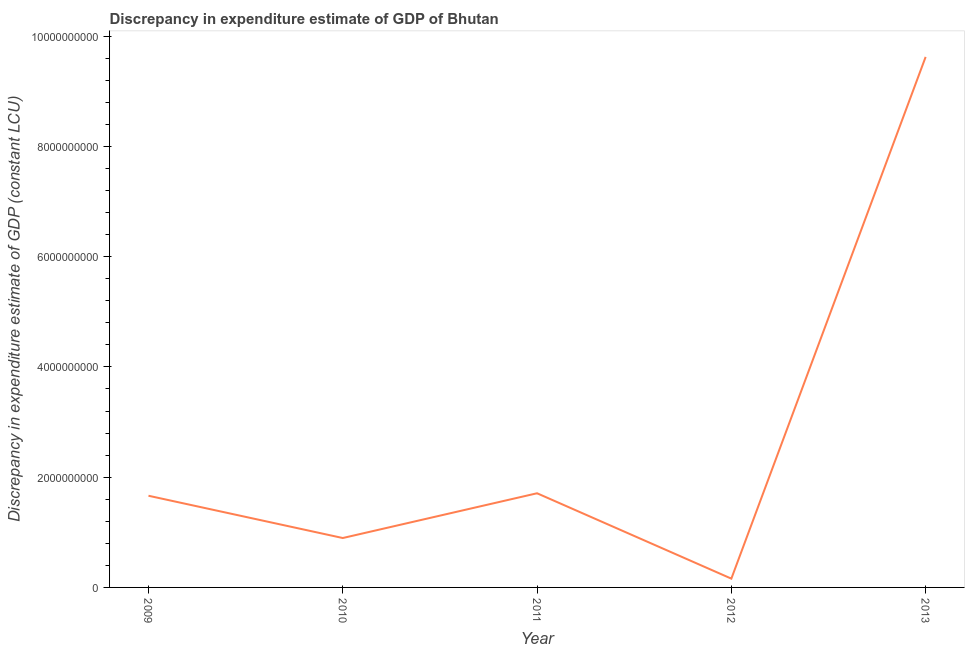What is the discrepancy in expenditure estimate of gdp in 2012?
Your answer should be compact. 1.59e+08. Across all years, what is the maximum discrepancy in expenditure estimate of gdp?
Ensure brevity in your answer.  9.62e+09. Across all years, what is the minimum discrepancy in expenditure estimate of gdp?
Offer a terse response. 1.59e+08. In which year was the discrepancy in expenditure estimate of gdp maximum?
Your answer should be compact. 2013. In which year was the discrepancy in expenditure estimate of gdp minimum?
Provide a succinct answer. 2012. What is the sum of the discrepancy in expenditure estimate of gdp?
Provide a short and direct response. 1.41e+1. What is the difference between the discrepancy in expenditure estimate of gdp in 2009 and 2012?
Keep it short and to the point. 1.50e+09. What is the average discrepancy in expenditure estimate of gdp per year?
Offer a very short reply. 2.81e+09. What is the median discrepancy in expenditure estimate of gdp?
Your answer should be compact. 1.66e+09. Do a majority of the years between 2013 and 2011 (inclusive) have discrepancy in expenditure estimate of gdp greater than 7600000000 LCU?
Your answer should be very brief. No. What is the ratio of the discrepancy in expenditure estimate of gdp in 2012 to that in 2013?
Offer a very short reply. 0.02. Is the discrepancy in expenditure estimate of gdp in 2012 less than that in 2013?
Your answer should be very brief. Yes. Is the difference between the discrepancy in expenditure estimate of gdp in 2010 and 2012 greater than the difference between any two years?
Keep it short and to the point. No. What is the difference between the highest and the second highest discrepancy in expenditure estimate of gdp?
Make the answer very short. 7.92e+09. What is the difference between the highest and the lowest discrepancy in expenditure estimate of gdp?
Provide a succinct answer. 9.46e+09. In how many years, is the discrepancy in expenditure estimate of gdp greater than the average discrepancy in expenditure estimate of gdp taken over all years?
Your response must be concise. 1. Does the discrepancy in expenditure estimate of gdp monotonically increase over the years?
Keep it short and to the point. No. How many lines are there?
Your answer should be very brief. 1. How many years are there in the graph?
Ensure brevity in your answer.  5. Does the graph contain any zero values?
Offer a terse response. No. What is the title of the graph?
Your response must be concise. Discrepancy in expenditure estimate of GDP of Bhutan. What is the label or title of the Y-axis?
Your response must be concise. Discrepancy in expenditure estimate of GDP (constant LCU). What is the Discrepancy in expenditure estimate of GDP (constant LCU) in 2009?
Your answer should be compact. 1.66e+09. What is the Discrepancy in expenditure estimate of GDP (constant LCU) of 2010?
Your answer should be compact. 8.96e+08. What is the Discrepancy in expenditure estimate of GDP (constant LCU) of 2011?
Offer a terse response. 1.71e+09. What is the Discrepancy in expenditure estimate of GDP (constant LCU) of 2012?
Your answer should be compact. 1.59e+08. What is the Discrepancy in expenditure estimate of GDP (constant LCU) of 2013?
Offer a very short reply. 9.62e+09. What is the difference between the Discrepancy in expenditure estimate of GDP (constant LCU) in 2009 and 2010?
Ensure brevity in your answer.  7.67e+08. What is the difference between the Discrepancy in expenditure estimate of GDP (constant LCU) in 2009 and 2011?
Your answer should be very brief. -4.51e+07. What is the difference between the Discrepancy in expenditure estimate of GDP (constant LCU) in 2009 and 2012?
Provide a succinct answer. 1.50e+09. What is the difference between the Discrepancy in expenditure estimate of GDP (constant LCU) in 2009 and 2013?
Offer a terse response. -7.96e+09. What is the difference between the Discrepancy in expenditure estimate of GDP (constant LCU) in 2010 and 2011?
Your answer should be compact. -8.12e+08. What is the difference between the Discrepancy in expenditure estimate of GDP (constant LCU) in 2010 and 2012?
Keep it short and to the point. 7.37e+08. What is the difference between the Discrepancy in expenditure estimate of GDP (constant LCU) in 2010 and 2013?
Provide a short and direct response. -8.73e+09. What is the difference between the Discrepancy in expenditure estimate of GDP (constant LCU) in 2011 and 2012?
Your answer should be very brief. 1.55e+09. What is the difference between the Discrepancy in expenditure estimate of GDP (constant LCU) in 2011 and 2013?
Ensure brevity in your answer.  -7.92e+09. What is the difference between the Discrepancy in expenditure estimate of GDP (constant LCU) in 2012 and 2013?
Offer a terse response. -9.46e+09. What is the ratio of the Discrepancy in expenditure estimate of GDP (constant LCU) in 2009 to that in 2010?
Offer a terse response. 1.86. What is the ratio of the Discrepancy in expenditure estimate of GDP (constant LCU) in 2009 to that in 2011?
Keep it short and to the point. 0.97. What is the ratio of the Discrepancy in expenditure estimate of GDP (constant LCU) in 2009 to that in 2012?
Offer a terse response. 10.44. What is the ratio of the Discrepancy in expenditure estimate of GDP (constant LCU) in 2009 to that in 2013?
Offer a very short reply. 0.17. What is the ratio of the Discrepancy in expenditure estimate of GDP (constant LCU) in 2010 to that in 2011?
Give a very brief answer. 0.53. What is the ratio of the Discrepancy in expenditure estimate of GDP (constant LCU) in 2010 to that in 2012?
Your answer should be very brief. 5.62. What is the ratio of the Discrepancy in expenditure estimate of GDP (constant LCU) in 2010 to that in 2013?
Provide a short and direct response. 0.09. What is the ratio of the Discrepancy in expenditure estimate of GDP (constant LCU) in 2011 to that in 2012?
Provide a short and direct response. 10.72. What is the ratio of the Discrepancy in expenditure estimate of GDP (constant LCU) in 2011 to that in 2013?
Your answer should be very brief. 0.18. What is the ratio of the Discrepancy in expenditure estimate of GDP (constant LCU) in 2012 to that in 2013?
Give a very brief answer. 0.02. 